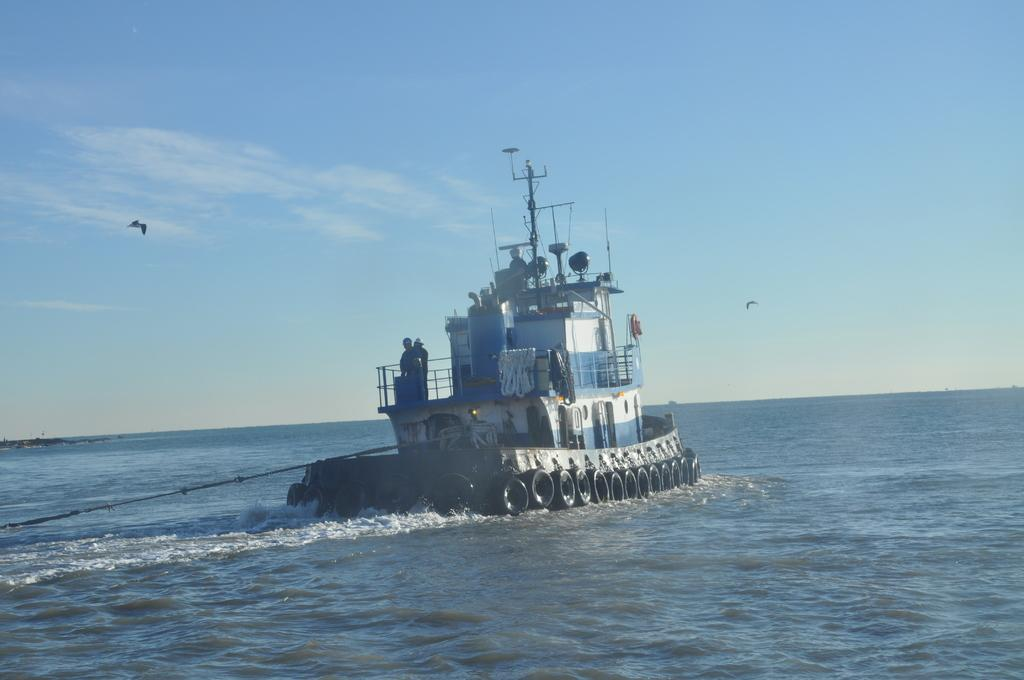What is the main subject of the image? The main subject of the image is a ship. What is the ship doing in the image? The ship is sailing on water. Are there any people on the ship? Yes, there are people standing on the ship. What is the condition of the water in the image? The water has tides. What is visible at the top of the image? The sky is visible at the top of the image. What else can be seen in the air in the image? There are birds flying in the air. What color is the eye of the orange in the image? There is no orange or eye present in the image. What decision did the people on the ship make in the image? The provided facts do not mention any decisions made by the people on the ship. 